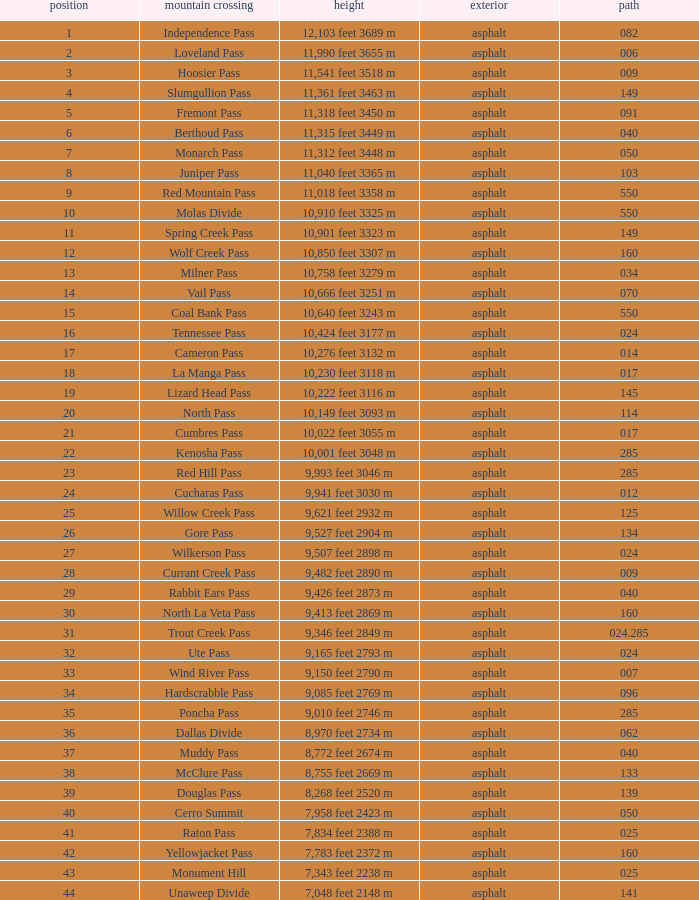Parse the full table. {'header': ['position', 'mountain crossing', 'height', 'exterior', 'path'], 'rows': [['1', 'Independence Pass', '12,103 feet 3689 m', 'asphalt', '082'], ['2', 'Loveland Pass', '11,990 feet 3655 m', 'asphalt', '006'], ['3', 'Hoosier Pass', '11,541 feet 3518 m', 'asphalt', '009'], ['4', 'Slumgullion Pass', '11,361 feet 3463 m', 'asphalt', '149'], ['5', 'Fremont Pass', '11,318 feet 3450 m', 'asphalt', '091'], ['6', 'Berthoud Pass', '11,315 feet 3449 m', 'asphalt', '040'], ['7', 'Monarch Pass', '11,312 feet 3448 m', 'asphalt', '050'], ['8', 'Juniper Pass', '11,040 feet 3365 m', 'asphalt', '103'], ['9', 'Red Mountain Pass', '11,018 feet 3358 m', 'asphalt', '550'], ['10', 'Molas Divide', '10,910 feet 3325 m', 'asphalt', '550'], ['11', 'Spring Creek Pass', '10,901 feet 3323 m', 'asphalt', '149'], ['12', 'Wolf Creek Pass', '10,850 feet 3307 m', 'asphalt', '160'], ['13', 'Milner Pass', '10,758 feet 3279 m', 'asphalt', '034'], ['14', 'Vail Pass', '10,666 feet 3251 m', 'asphalt', '070'], ['15', 'Coal Bank Pass', '10,640 feet 3243 m', 'asphalt', '550'], ['16', 'Tennessee Pass', '10,424 feet 3177 m', 'asphalt', '024'], ['17', 'Cameron Pass', '10,276 feet 3132 m', 'asphalt', '014'], ['18', 'La Manga Pass', '10,230 feet 3118 m', 'asphalt', '017'], ['19', 'Lizard Head Pass', '10,222 feet 3116 m', 'asphalt', '145'], ['20', 'North Pass', '10,149 feet 3093 m', 'asphalt', '114'], ['21', 'Cumbres Pass', '10,022 feet 3055 m', 'asphalt', '017'], ['22', 'Kenosha Pass', '10,001 feet 3048 m', 'asphalt', '285'], ['23', 'Red Hill Pass', '9,993 feet 3046 m', 'asphalt', '285'], ['24', 'Cucharas Pass', '9,941 feet 3030 m', 'asphalt', '012'], ['25', 'Willow Creek Pass', '9,621 feet 2932 m', 'asphalt', '125'], ['26', 'Gore Pass', '9,527 feet 2904 m', 'asphalt', '134'], ['27', 'Wilkerson Pass', '9,507 feet 2898 m', 'asphalt', '024'], ['28', 'Currant Creek Pass', '9,482 feet 2890 m', 'asphalt', '009'], ['29', 'Rabbit Ears Pass', '9,426 feet 2873 m', 'asphalt', '040'], ['30', 'North La Veta Pass', '9,413 feet 2869 m', 'asphalt', '160'], ['31', 'Trout Creek Pass', '9,346 feet 2849 m', 'asphalt', '024.285'], ['32', 'Ute Pass', '9,165 feet 2793 m', 'asphalt', '024'], ['33', 'Wind River Pass', '9,150 feet 2790 m', 'asphalt', '007'], ['34', 'Hardscrabble Pass', '9,085 feet 2769 m', 'asphalt', '096'], ['35', 'Poncha Pass', '9,010 feet 2746 m', 'asphalt', '285'], ['36', 'Dallas Divide', '8,970 feet 2734 m', 'asphalt', '062'], ['37', 'Muddy Pass', '8,772 feet 2674 m', 'asphalt', '040'], ['38', 'McClure Pass', '8,755 feet 2669 m', 'asphalt', '133'], ['39', 'Douglas Pass', '8,268 feet 2520 m', 'asphalt', '139'], ['40', 'Cerro Summit', '7,958 feet 2423 m', 'asphalt', '050'], ['41', 'Raton Pass', '7,834 feet 2388 m', 'asphalt', '025'], ['42', 'Yellowjacket Pass', '7,783 feet 2372 m', 'asphalt', '160'], ['43', 'Monument Hill', '7,343 feet 2238 m', 'asphalt', '025'], ['44', 'Unaweep Divide', '7,048 feet 2148 m', 'asphalt', '141']]} On what Route is the mountain with a Rank less than 33 and an Elevation of 11,312 feet 3448 m? 50.0. 